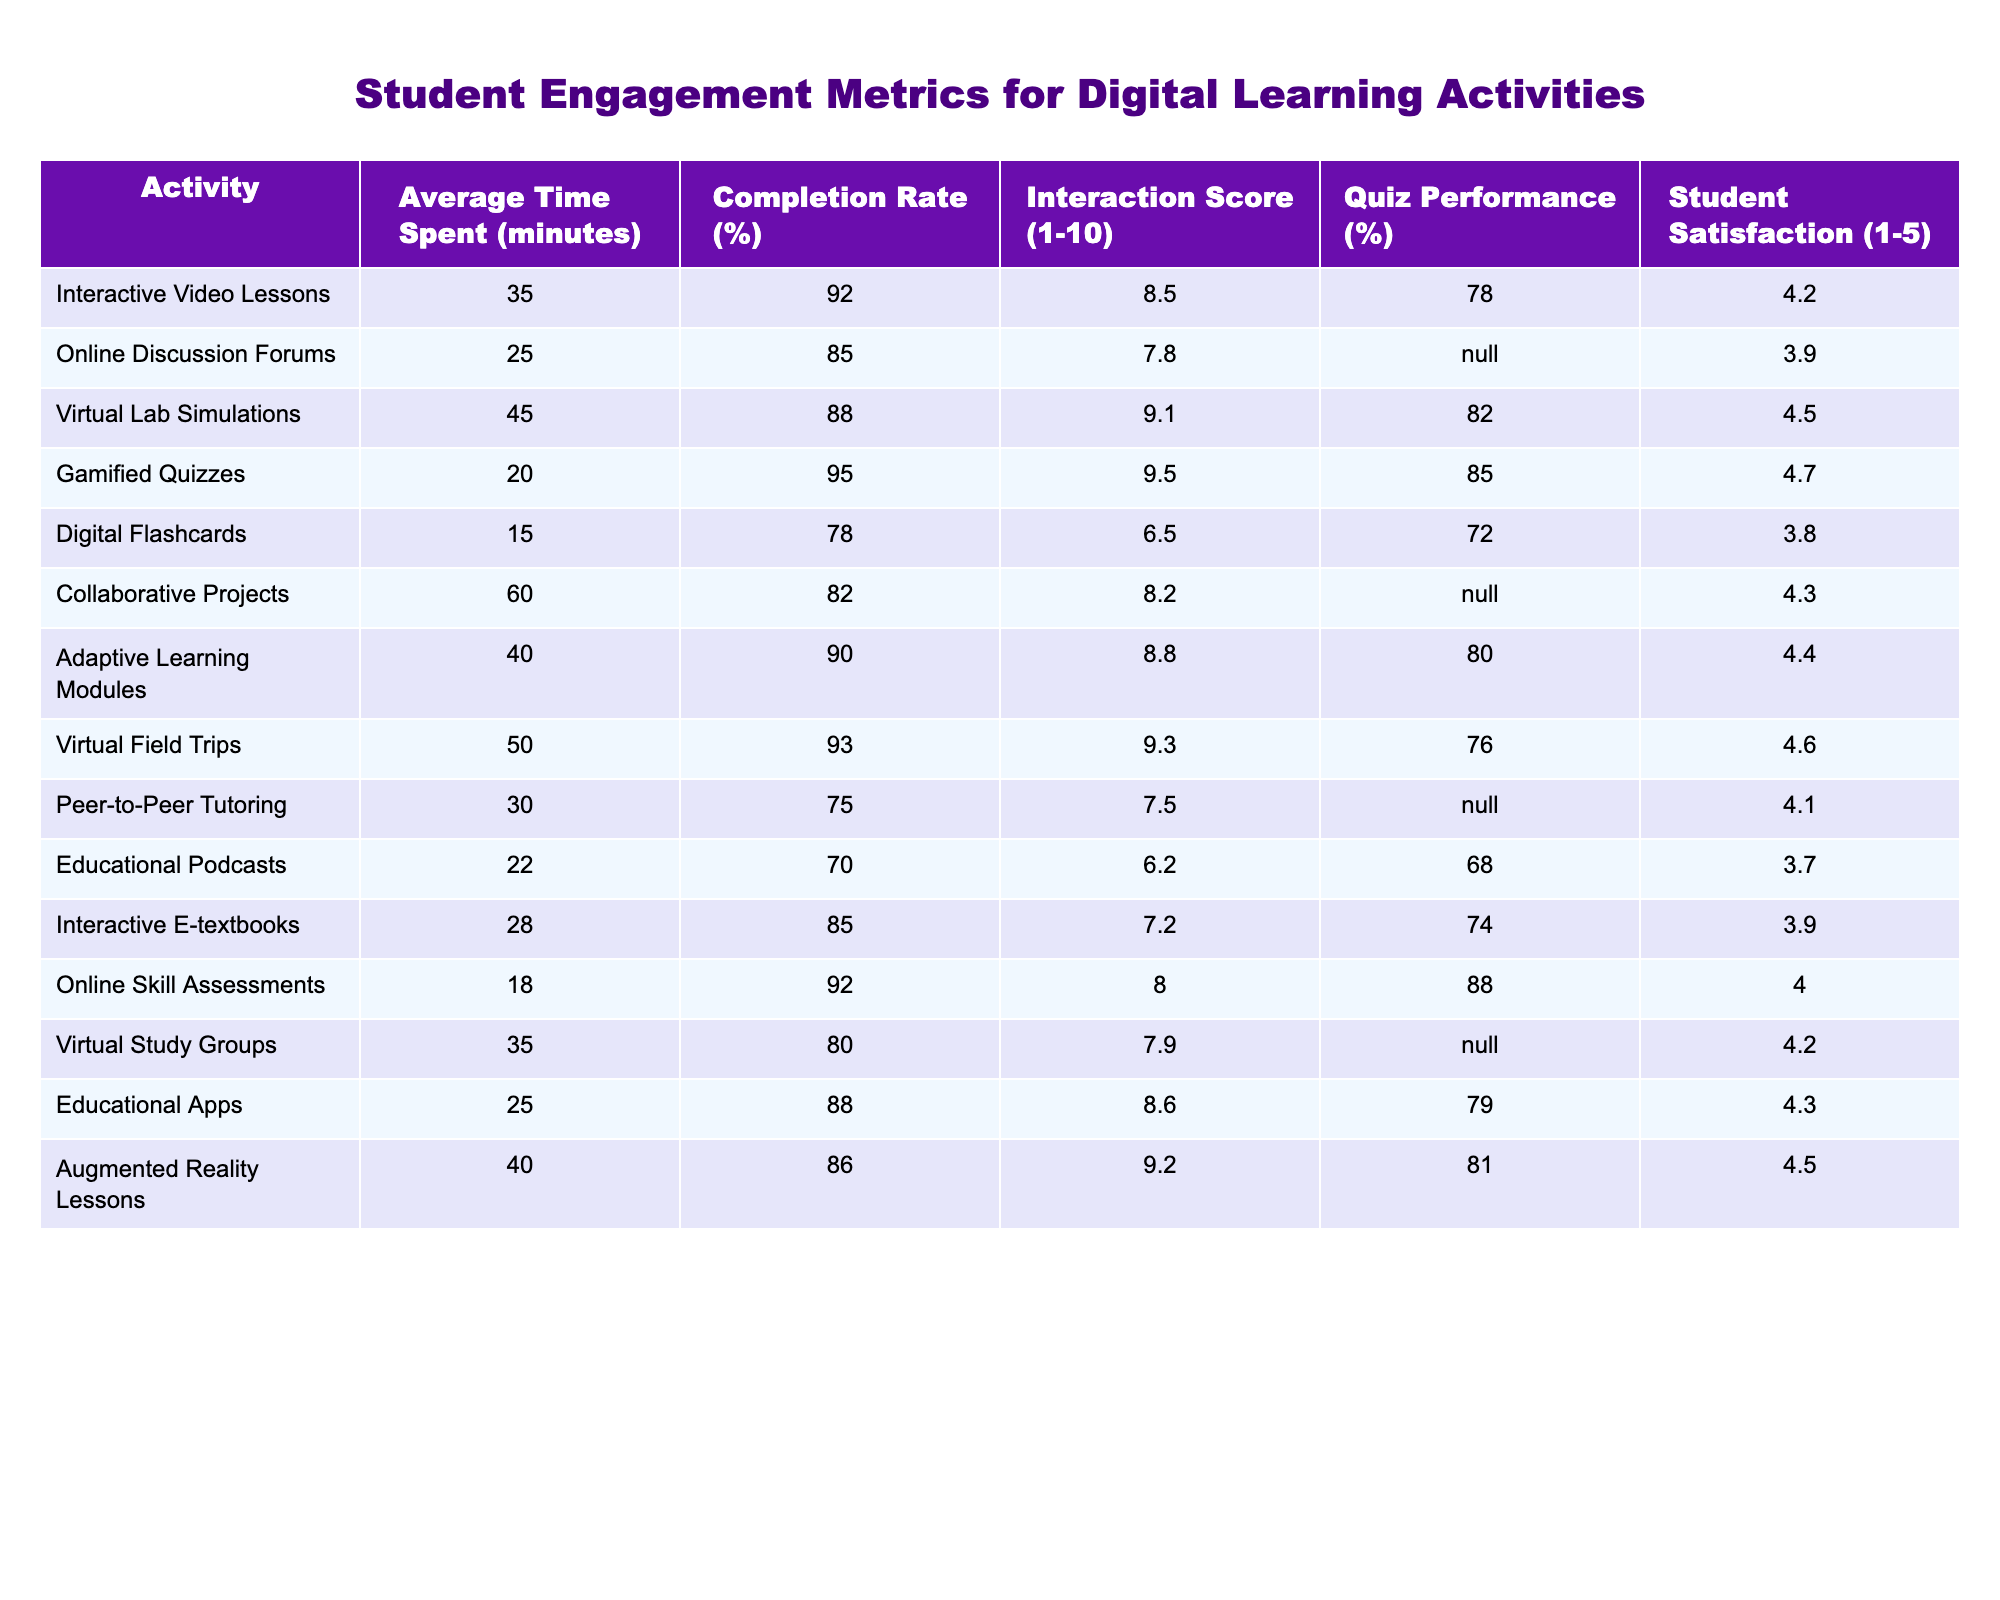What is the average time spent on Interactive Video Lessons? The table indicates the average time spent on Interactive Video Lessons is represented in minutes. Looking at the corresponding value, it states 35 minutes.
Answer: 35 minutes Which learning activity has the highest completion rate? By examining the completion rates listed, Gamified Quizzes shows a completion rate of 95%. This is higher than all other activities listed.
Answer: Gamified Quizzes What is the interaction score for Virtual Lab Simulations? The interaction score for each activity can be found in the Interaction Score column. For Virtual Lab Simulations, the score is 9.1.
Answer: 9.1 Is the Quiz Performance for Online Discussion Forums available? The table shows that the Quiz Performance for Online Discussion Forums is marked as N/A. This means there is no available data for this activity.
Answer: No Which activity has the lowest student satisfaction score? I will check the Student Satisfaction column for the lowest value. Educational Podcasts has the lowest score at 3.7.
Answer: Educational Podcasts What is the average completion rate for all activities? First, I will sum up all the completion rates: 92 + 85 + 88 + 95 + 78 + 82 + 90 + 93 + 75 + 70 + 85 + 92 + 80 + 88 + 86 =  1,249. Next, I will divide this sum by the total number of activities, which is 15: 1,249 / 15 = about 83.27%.
Answer: 83.27% Compare the average time spent on Collaborative Projects and Virtual Field Trips. The average time spent on Collaborative Projects is 60 minutes, while for Virtual Field Trips, it is 50 minutes. Thus, Collaborative Projects takes 10 minutes longer.
Answer: Collaborative Projects is longer by 10 minutes Based on the data, which digital learning activity has the highest interaction score and how does it compare to the next highest? I will check the Interaction Score column for the highest value. Gamified Quizzes has the highest score at 9.5, followed by Virtual Lab Simulations at 9.1. The difference is 0.4.
Answer: Gamified Quizzes, difference is 0.4 How many activities have a Completion Rate below 80%? I will review the Completion Rate column and count the activities with rates below 80%. Those are Digital Flashcards (78%) and Peer-to-Peer Tutoring (75%). Therefore, 2 activities meet this criterion.
Answer: 2 activities Which activity has the highest student satisfaction and what is its score? Looking at the Student Satisfaction column, Gamified Quizzes has the highest score of 4.7.
Answer: 4.7 What is the difference in quiz performance between Gamified Quizzes and Digital Flashcards? The Quiz Performance for Gamified Quizzes is 85%, while for Digital Flashcards, it is 72%. The difference is calculated as 85 - 72 = 13%.
Answer: 13% difference 